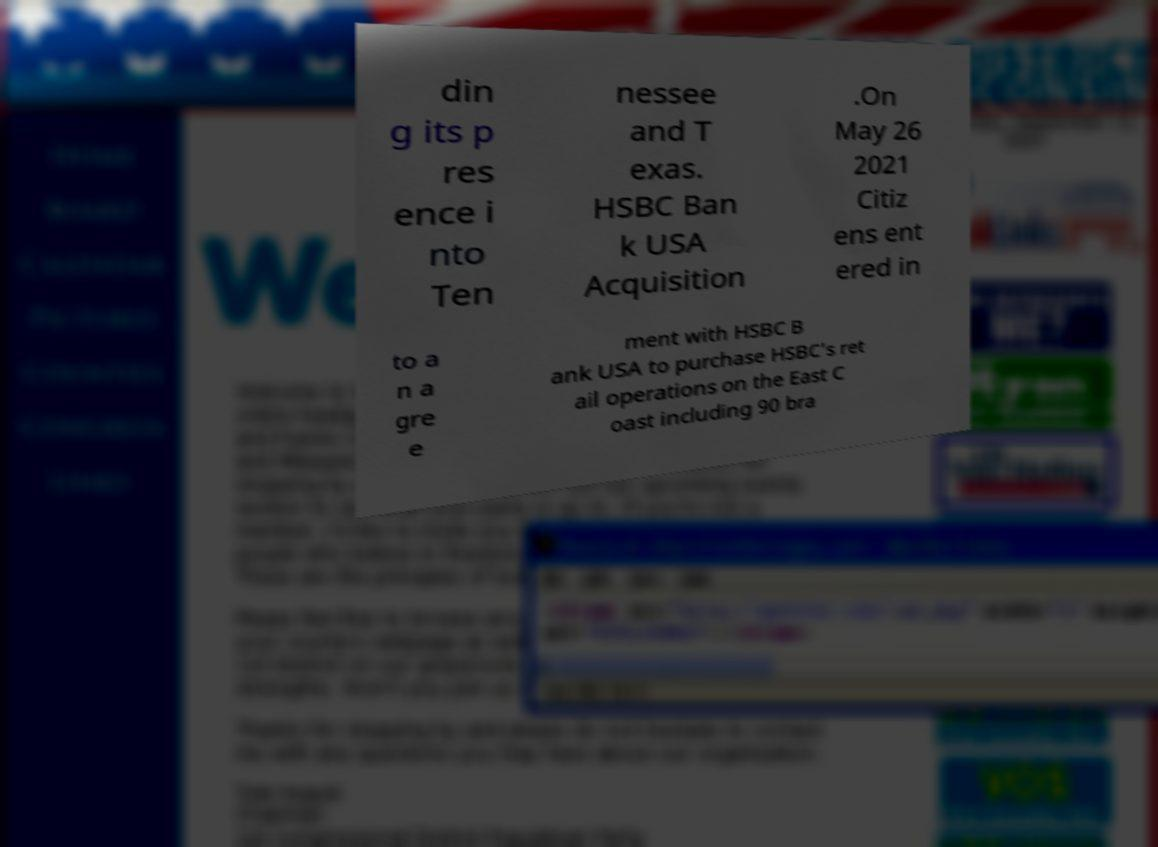Please identify and transcribe the text found in this image. din g its p res ence i nto Ten nessee and T exas. HSBC Ban k USA Acquisition .On May 26 2021 Citiz ens ent ered in to a n a gre e ment with HSBC B ank USA to purchase HSBC's ret ail operations on the East C oast including 90 bra 